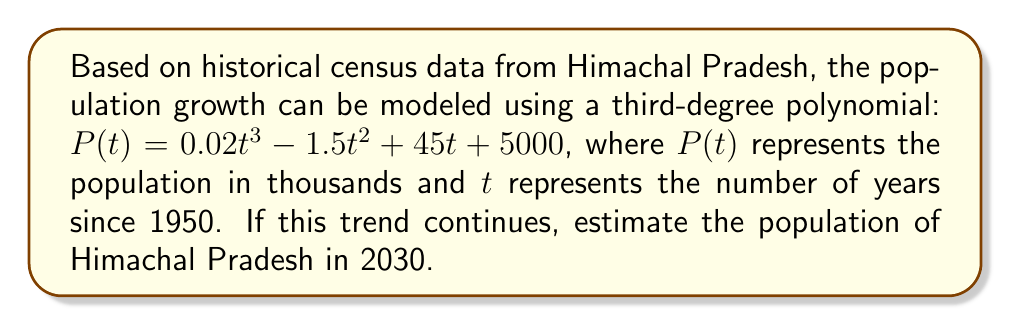Show me your answer to this math problem. To solve this problem, we need to follow these steps:

1) First, we need to determine the value of $t$ for the year 2030. Since $t$ represents the number of years since 1950:

   $t_{2030} = 2030 - 1950 = 80$

2) Now, we can substitute this value into our polynomial function:

   $P(80) = 0.02(80)^3 - 1.5(80)^2 + 45(80) + 5000$

3) Let's calculate each term:

   $0.02(80)^3 = 0.02 * 512000 = 10240$
   $-1.5(80)^2 = -1.5 * 6400 = -9600$
   $45(80) = 3600$
   $5000$ remains as is

4) Now, we can add these terms:

   $P(80) = 10240 - 9600 + 3600 + 5000 = 9240$

5) Remember that $P(t)$ represents the population in thousands, so we need to multiply our result by 1000:

   $9240 * 1000 = 9,240,000$

Therefore, if this polynomial trend continues, the estimated population of Himachal Pradesh in 2030 would be 9,240,000.
Answer: 9,240,000 